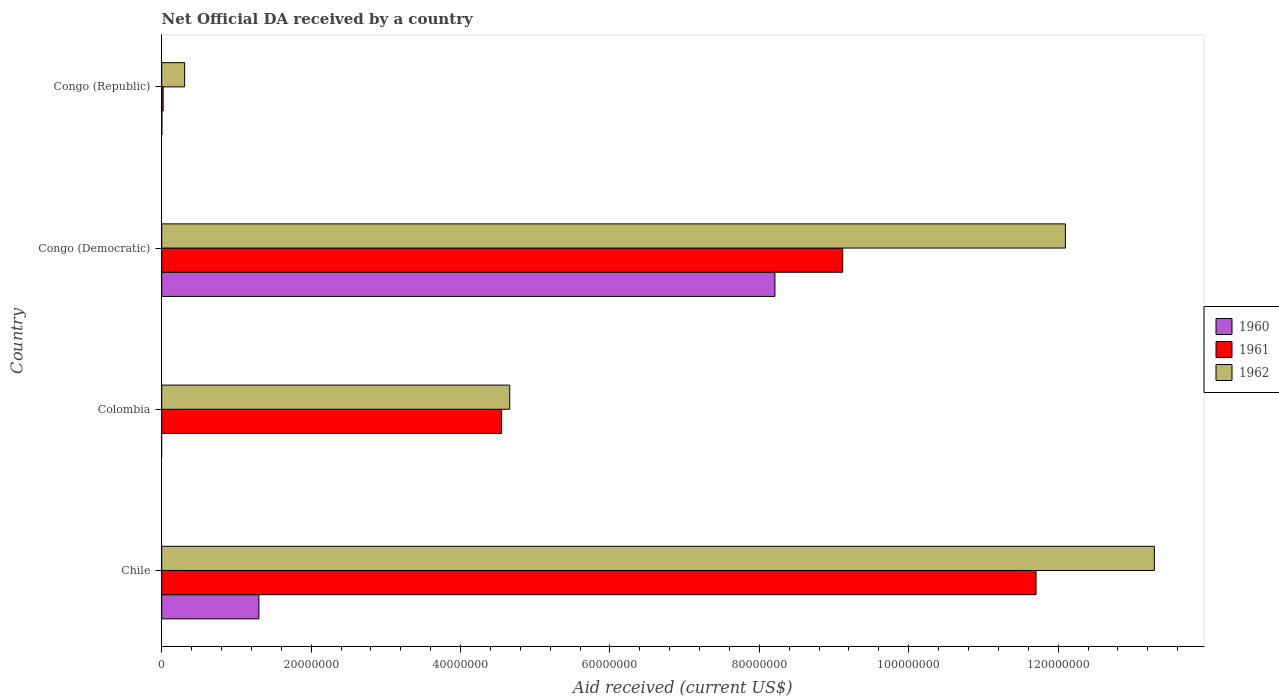How many different coloured bars are there?
Provide a succinct answer. 3. How many groups of bars are there?
Provide a short and direct response. 4. Are the number of bars per tick equal to the number of legend labels?
Provide a succinct answer. No. What is the net official development assistance aid received in 1961 in Colombia?
Make the answer very short. 4.55e+07. Across all countries, what is the maximum net official development assistance aid received in 1960?
Offer a very short reply. 8.21e+07. Across all countries, what is the minimum net official development assistance aid received in 1961?
Provide a succinct answer. 1.90e+05. In which country was the net official development assistance aid received in 1960 maximum?
Offer a terse response. Congo (Democratic). What is the total net official development assistance aid received in 1961 in the graph?
Make the answer very short. 2.54e+08. What is the difference between the net official development assistance aid received in 1962 in Chile and that in Congo (Democratic)?
Provide a succinct answer. 1.19e+07. What is the difference between the net official development assistance aid received in 1960 in Congo (Republic) and the net official development assistance aid received in 1962 in Chile?
Give a very brief answer. -1.33e+08. What is the average net official development assistance aid received in 1962 per country?
Provide a succinct answer. 7.59e+07. What is the difference between the net official development assistance aid received in 1960 and net official development assistance aid received in 1962 in Chile?
Provide a succinct answer. -1.20e+08. What is the ratio of the net official development assistance aid received in 1961 in Congo (Democratic) to that in Congo (Republic)?
Give a very brief answer. 479.79. Is the net official development assistance aid received in 1962 in Colombia less than that in Congo (Republic)?
Give a very brief answer. No. What is the difference between the highest and the second highest net official development assistance aid received in 1961?
Offer a terse response. 2.59e+07. What is the difference between the highest and the lowest net official development assistance aid received in 1960?
Provide a short and direct response. 8.21e+07. In how many countries, is the net official development assistance aid received in 1962 greater than the average net official development assistance aid received in 1962 taken over all countries?
Offer a very short reply. 2. Is it the case that in every country, the sum of the net official development assistance aid received in 1961 and net official development assistance aid received in 1962 is greater than the net official development assistance aid received in 1960?
Your answer should be very brief. Yes. Are all the bars in the graph horizontal?
Offer a terse response. Yes. How many countries are there in the graph?
Your answer should be very brief. 4. Does the graph contain any zero values?
Your answer should be compact. Yes. How many legend labels are there?
Give a very brief answer. 3. What is the title of the graph?
Your response must be concise. Net Official DA received by a country. What is the label or title of the X-axis?
Your response must be concise. Aid received (current US$). What is the label or title of the Y-axis?
Your answer should be very brief. Country. What is the Aid received (current US$) of 1960 in Chile?
Offer a very short reply. 1.30e+07. What is the Aid received (current US$) of 1961 in Chile?
Provide a short and direct response. 1.17e+08. What is the Aid received (current US$) in 1962 in Chile?
Offer a very short reply. 1.33e+08. What is the Aid received (current US$) in 1960 in Colombia?
Give a very brief answer. 0. What is the Aid received (current US$) of 1961 in Colombia?
Give a very brief answer. 4.55e+07. What is the Aid received (current US$) in 1962 in Colombia?
Your answer should be very brief. 4.66e+07. What is the Aid received (current US$) in 1960 in Congo (Democratic)?
Make the answer very short. 8.21e+07. What is the Aid received (current US$) in 1961 in Congo (Democratic)?
Your response must be concise. 9.12e+07. What is the Aid received (current US$) in 1962 in Congo (Democratic)?
Make the answer very short. 1.21e+08. What is the Aid received (current US$) in 1961 in Congo (Republic)?
Keep it short and to the point. 1.90e+05. What is the Aid received (current US$) in 1962 in Congo (Republic)?
Provide a succinct answer. 3.07e+06. Across all countries, what is the maximum Aid received (current US$) of 1960?
Offer a very short reply. 8.21e+07. Across all countries, what is the maximum Aid received (current US$) of 1961?
Your answer should be compact. 1.17e+08. Across all countries, what is the maximum Aid received (current US$) in 1962?
Ensure brevity in your answer.  1.33e+08. Across all countries, what is the minimum Aid received (current US$) in 1960?
Offer a very short reply. 0. Across all countries, what is the minimum Aid received (current US$) in 1962?
Provide a succinct answer. 3.07e+06. What is the total Aid received (current US$) of 1960 in the graph?
Keep it short and to the point. 9.51e+07. What is the total Aid received (current US$) in 1961 in the graph?
Your response must be concise. 2.54e+08. What is the total Aid received (current US$) of 1962 in the graph?
Give a very brief answer. 3.04e+08. What is the difference between the Aid received (current US$) of 1961 in Chile and that in Colombia?
Make the answer very short. 7.15e+07. What is the difference between the Aid received (current US$) in 1962 in Chile and that in Colombia?
Offer a very short reply. 8.63e+07. What is the difference between the Aid received (current US$) in 1960 in Chile and that in Congo (Democratic)?
Provide a succinct answer. -6.91e+07. What is the difference between the Aid received (current US$) in 1961 in Chile and that in Congo (Democratic)?
Offer a very short reply. 2.59e+07. What is the difference between the Aid received (current US$) in 1962 in Chile and that in Congo (Democratic)?
Offer a very short reply. 1.19e+07. What is the difference between the Aid received (current US$) in 1960 in Chile and that in Congo (Republic)?
Provide a succinct answer. 1.30e+07. What is the difference between the Aid received (current US$) of 1961 in Chile and that in Congo (Republic)?
Keep it short and to the point. 1.17e+08. What is the difference between the Aid received (current US$) of 1962 in Chile and that in Congo (Republic)?
Keep it short and to the point. 1.30e+08. What is the difference between the Aid received (current US$) of 1961 in Colombia and that in Congo (Democratic)?
Your answer should be compact. -4.57e+07. What is the difference between the Aid received (current US$) of 1962 in Colombia and that in Congo (Democratic)?
Keep it short and to the point. -7.44e+07. What is the difference between the Aid received (current US$) in 1961 in Colombia and that in Congo (Republic)?
Your response must be concise. 4.53e+07. What is the difference between the Aid received (current US$) of 1962 in Colombia and that in Congo (Republic)?
Offer a very short reply. 4.35e+07. What is the difference between the Aid received (current US$) in 1960 in Congo (Democratic) and that in Congo (Republic)?
Keep it short and to the point. 8.21e+07. What is the difference between the Aid received (current US$) in 1961 in Congo (Democratic) and that in Congo (Republic)?
Give a very brief answer. 9.10e+07. What is the difference between the Aid received (current US$) in 1962 in Congo (Democratic) and that in Congo (Republic)?
Make the answer very short. 1.18e+08. What is the difference between the Aid received (current US$) of 1960 in Chile and the Aid received (current US$) of 1961 in Colombia?
Your response must be concise. -3.25e+07. What is the difference between the Aid received (current US$) of 1960 in Chile and the Aid received (current US$) of 1962 in Colombia?
Offer a terse response. -3.36e+07. What is the difference between the Aid received (current US$) of 1961 in Chile and the Aid received (current US$) of 1962 in Colombia?
Your answer should be compact. 7.04e+07. What is the difference between the Aid received (current US$) of 1960 in Chile and the Aid received (current US$) of 1961 in Congo (Democratic)?
Give a very brief answer. -7.82e+07. What is the difference between the Aid received (current US$) of 1960 in Chile and the Aid received (current US$) of 1962 in Congo (Democratic)?
Make the answer very short. -1.08e+08. What is the difference between the Aid received (current US$) in 1961 in Chile and the Aid received (current US$) in 1962 in Congo (Democratic)?
Provide a succinct answer. -3.93e+06. What is the difference between the Aid received (current US$) in 1960 in Chile and the Aid received (current US$) in 1961 in Congo (Republic)?
Your answer should be compact. 1.28e+07. What is the difference between the Aid received (current US$) in 1960 in Chile and the Aid received (current US$) in 1962 in Congo (Republic)?
Give a very brief answer. 9.94e+06. What is the difference between the Aid received (current US$) in 1961 in Chile and the Aid received (current US$) in 1962 in Congo (Republic)?
Make the answer very short. 1.14e+08. What is the difference between the Aid received (current US$) in 1961 in Colombia and the Aid received (current US$) in 1962 in Congo (Democratic)?
Keep it short and to the point. -7.55e+07. What is the difference between the Aid received (current US$) in 1961 in Colombia and the Aid received (current US$) in 1962 in Congo (Republic)?
Ensure brevity in your answer.  4.24e+07. What is the difference between the Aid received (current US$) in 1960 in Congo (Democratic) and the Aid received (current US$) in 1961 in Congo (Republic)?
Provide a succinct answer. 8.19e+07. What is the difference between the Aid received (current US$) of 1960 in Congo (Democratic) and the Aid received (current US$) of 1962 in Congo (Republic)?
Ensure brevity in your answer.  7.90e+07. What is the difference between the Aid received (current US$) of 1961 in Congo (Democratic) and the Aid received (current US$) of 1962 in Congo (Republic)?
Offer a very short reply. 8.81e+07. What is the average Aid received (current US$) of 1960 per country?
Give a very brief answer. 2.38e+07. What is the average Aid received (current US$) of 1961 per country?
Your response must be concise. 6.35e+07. What is the average Aid received (current US$) in 1962 per country?
Make the answer very short. 7.59e+07. What is the difference between the Aid received (current US$) of 1960 and Aid received (current US$) of 1961 in Chile?
Make the answer very short. -1.04e+08. What is the difference between the Aid received (current US$) in 1960 and Aid received (current US$) in 1962 in Chile?
Your response must be concise. -1.20e+08. What is the difference between the Aid received (current US$) of 1961 and Aid received (current US$) of 1962 in Chile?
Make the answer very short. -1.58e+07. What is the difference between the Aid received (current US$) in 1961 and Aid received (current US$) in 1962 in Colombia?
Your response must be concise. -1.09e+06. What is the difference between the Aid received (current US$) of 1960 and Aid received (current US$) of 1961 in Congo (Democratic)?
Provide a short and direct response. -9.07e+06. What is the difference between the Aid received (current US$) in 1960 and Aid received (current US$) in 1962 in Congo (Democratic)?
Provide a succinct answer. -3.89e+07. What is the difference between the Aid received (current US$) in 1961 and Aid received (current US$) in 1962 in Congo (Democratic)?
Provide a short and direct response. -2.98e+07. What is the difference between the Aid received (current US$) of 1960 and Aid received (current US$) of 1962 in Congo (Republic)?
Make the answer very short. -3.05e+06. What is the difference between the Aid received (current US$) in 1961 and Aid received (current US$) in 1962 in Congo (Republic)?
Give a very brief answer. -2.88e+06. What is the ratio of the Aid received (current US$) of 1961 in Chile to that in Colombia?
Give a very brief answer. 2.57. What is the ratio of the Aid received (current US$) of 1962 in Chile to that in Colombia?
Keep it short and to the point. 2.85. What is the ratio of the Aid received (current US$) of 1960 in Chile to that in Congo (Democratic)?
Provide a succinct answer. 0.16. What is the ratio of the Aid received (current US$) in 1961 in Chile to that in Congo (Democratic)?
Your response must be concise. 1.28. What is the ratio of the Aid received (current US$) of 1962 in Chile to that in Congo (Democratic)?
Your response must be concise. 1.1. What is the ratio of the Aid received (current US$) in 1960 in Chile to that in Congo (Republic)?
Offer a very short reply. 650.5. What is the ratio of the Aid received (current US$) of 1961 in Chile to that in Congo (Republic)?
Offer a very short reply. 616. What is the ratio of the Aid received (current US$) of 1962 in Chile to that in Congo (Republic)?
Your answer should be compact. 43.28. What is the ratio of the Aid received (current US$) of 1961 in Colombia to that in Congo (Democratic)?
Make the answer very short. 0.5. What is the ratio of the Aid received (current US$) of 1962 in Colombia to that in Congo (Democratic)?
Your answer should be compact. 0.39. What is the ratio of the Aid received (current US$) in 1961 in Colombia to that in Congo (Republic)?
Provide a short and direct response. 239.47. What is the ratio of the Aid received (current US$) in 1962 in Colombia to that in Congo (Republic)?
Provide a short and direct response. 15.18. What is the ratio of the Aid received (current US$) in 1960 in Congo (Democratic) to that in Congo (Republic)?
Your answer should be very brief. 4104.5. What is the ratio of the Aid received (current US$) of 1961 in Congo (Democratic) to that in Congo (Republic)?
Make the answer very short. 479.79. What is the ratio of the Aid received (current US$) in 1962 in Congo (Democratic) to that in Congo (Republic)?
Your answer should be compact. 39.4. What is the difference between the highest and the second highest Aid received (current US$) of 1960?
Provide a short and direct response. 6.91e+07. What is the difference between the highest and the second highest Aid received (current US$) in 1961?
Your answer should be very brief. 2.59e+07. What is the difference between the highest and the second highest Aid received (current US$) of 1962?
Offer a terse response. 1.19e+07. What is the difference between the highest and the lowest Aid received (current US$) of 1960?
Offer a terse response. 8.21e+07. What is the difference between the highest and the lowest Aid received (current US$) of 1961?
Ensure brevity in your answer.  1.17e+08. What is the difference between the highest and the lowest Aid received (current US$) of 1962?
Make the answer very short. 1.30e+08. 